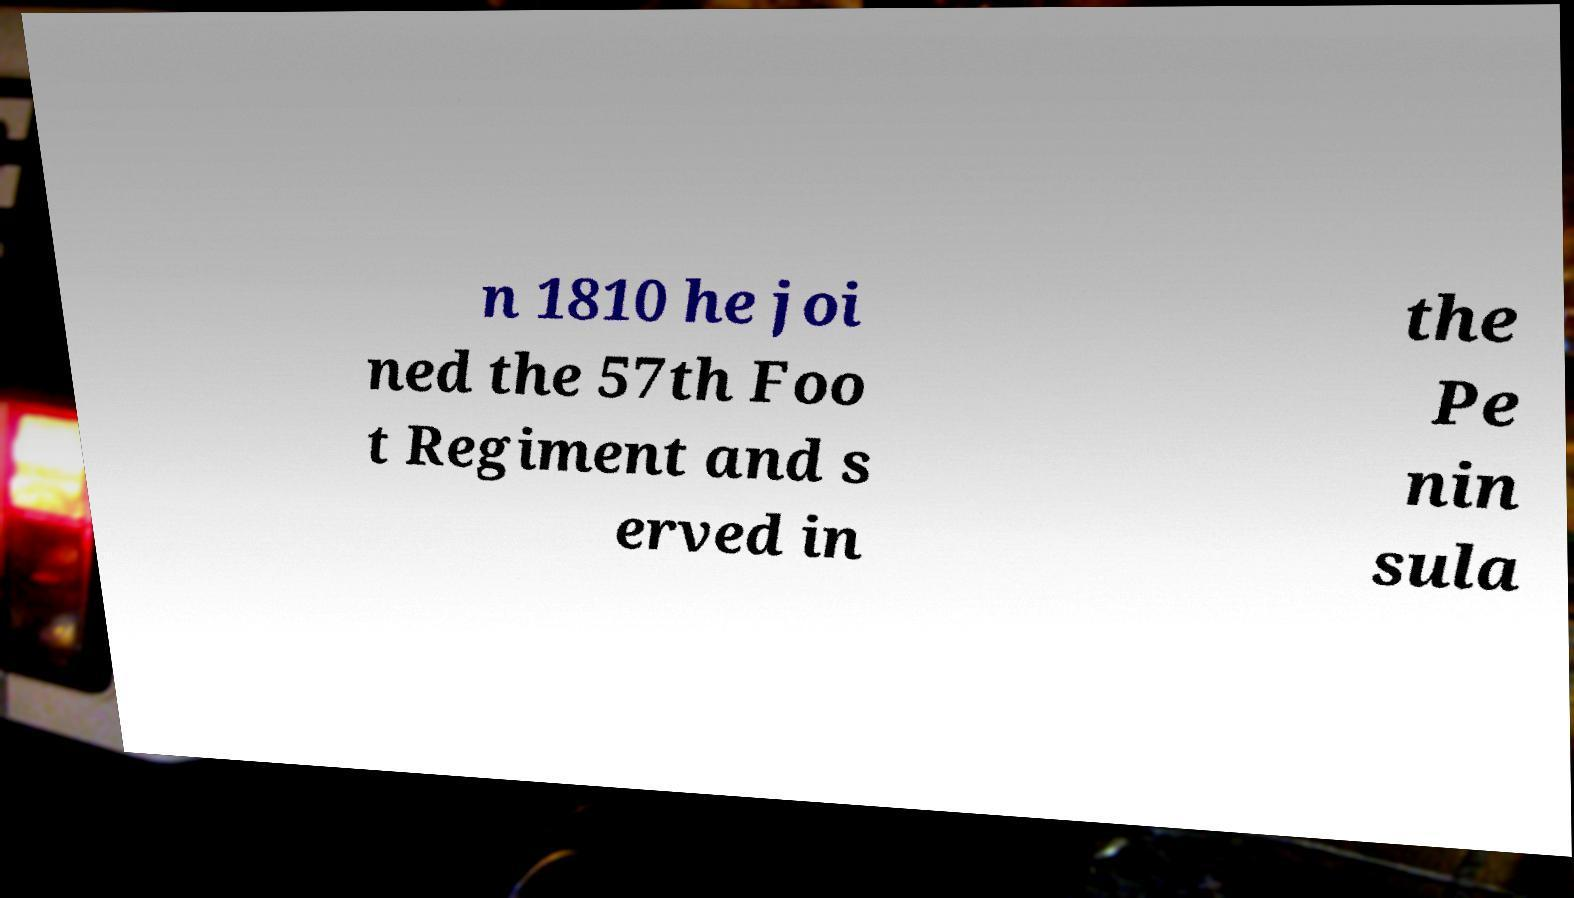Could you extract and type out the text from this image? n 1810 he joi ned the 57th Foo t Regiment and s erved in the Pe nin sula 